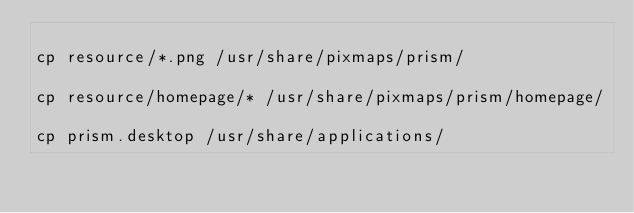Convert code to text. <code><loc_0><loc_0><loc_500><loc_500><_Bash_>
cp resource/*.png /usr/share/pixmaps/prism/

cp resource/homepage/* /usr/share/pixmaps/prism/homepage/

cp prism.desktop /usr/share/applications/
</code> 